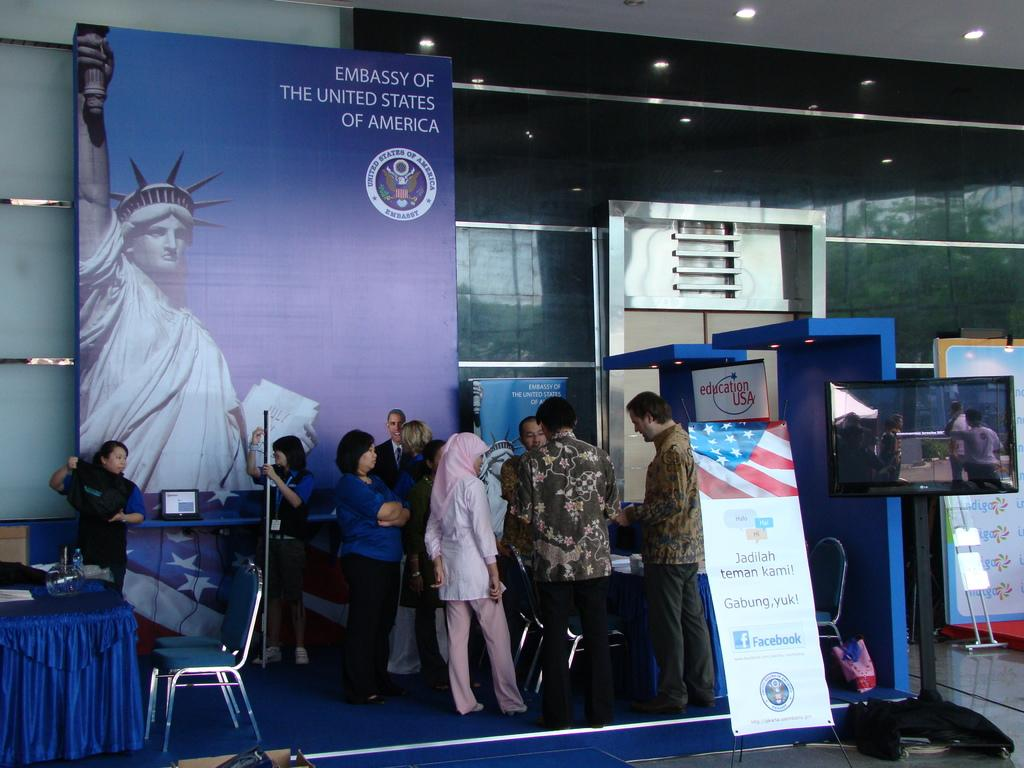What can be seen in the image in terms of people? There are people standing in the image. What type of furniture is present in the image? There are chairs and tables in the image. What kind of signage is visible in the image? There are advertisement boards in the image. What electronic device can be seen in the image? There is a laptop in the image. What type of lighting is present in the image? There are electric lights in the image. What natural elements are visible in the image? There are trees in the image. Can you see any pens being used by the people in the image? There is no mention of pens in the image, so we cannot determine if any are being used. Are there any balls visible in the image? There is no mention of balls in the image, so we cannot determine if any are present. 